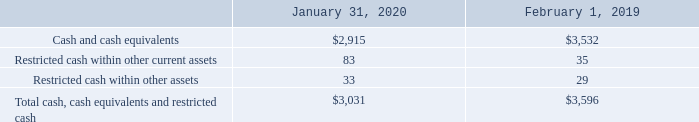Restricted Cash
The following table provides a reconciliation of the Company’s cash and cash equivalents, and current and non-current portion of restricted cash reported on the consolidated balance sheets that sum to the total cash, cash equivalents and restricted cash as of January 31, 2020 and February 1, 2019 (table in millions):
Amounts included in restricted cash primarily relate to certain employee-related benefits, as well as amounts related to installment payments to certain employees as part of acquisitions, subject to the achievement of specified future employment conditions.
What do amounts included in restricted cash primarily relate to? Certain employee-related benefits, as well as amounts related to installment payments to certain employees as part of acquisitions, subject to the achievement of specified future employment conditions. What was the amount of Restricted cash within other current assets in 2019?
Answer scale should be: million. 35. What were the Total cash, cash equivalents and restricted cash in 2020?
Answer scale should be: million. 3,031. What was the change in Restricted cash within other assets between 2019 and 2020?
Answer scale should be: million. 33-29
Answer: 4. What was the change in Restricted cash within other current assets between 2019 and 2020?
Answer scale should be: million. 83-35
Answer: 48. What was the percentage change in the total cash, cash equivalents and restricted cash between 2019 and 2020?
Answer scale should be: percent. (3,031-3,596)/3,596
Answer: -15.71. 